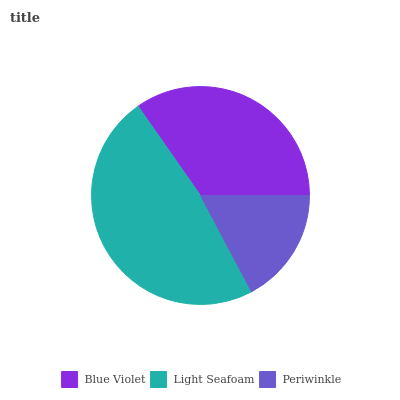Is Periwinkle the minimum?
Answer yes or no. Yes. Is Light Seafoam the maximum?
Answer yes or no. Yes. Is Light Seafoam the minimum?
Answer yes or no. No. Is Periwinkle the maximum?
Answer yes or no. No. Is Light Seafoam greater than Periwinkle?
Answer yes or no. Yes. Is Periwinkle less than Light Seafoam?
Answer yes or no. Yes. Is Periwinkle greater than Light Seafoam?
Answer yes or no. No. Is Light Seafoam less than Periwinkle?
Answer yes or no. No. Is Blue Violet the high median?
Answer yes or no. Yes. Is Blue Violet the low median?
Answer yes or no. Yes. Is Light Seafoam the high median?
Answer yes or no. No. Is Light Seafoam the low median?
Answer yes or no. No. 